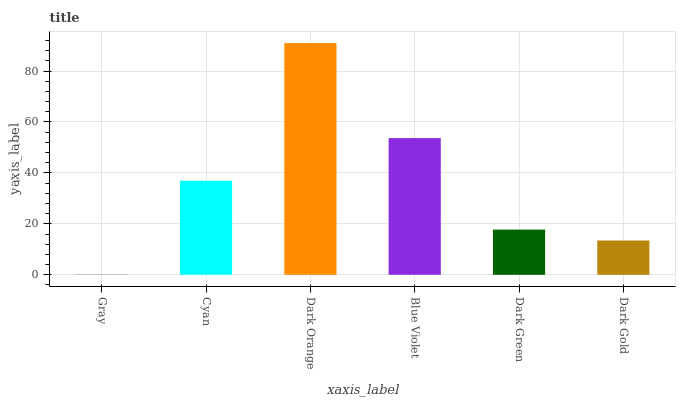Is Gray the minimum?
Answer yes or no. Yes. Is Dark Orange the maximum?
Answer yes or no. Yes. Is Cyan the minimum?
Answer yes or no. No. Is Cyan the maximum?
Answer yes or no. No. Is Cyan greater than Gray?
Answer yes or no. Yes. Is Gray less than Cyan?
Answer yes or no. Yes. Is Gray greater than Cyan?
Answer yes or no. No. Is Cyan less than Gray?
Answer yes or no. No. Is Cyan the high median?
Answer yes or no. Yes. Is Dark Green the low median?
Answer yes or no. Yes. Is Dark Gold the high median?
Answer yes or no. No. Is Cyan the low median?
Answer yes or no. No. 